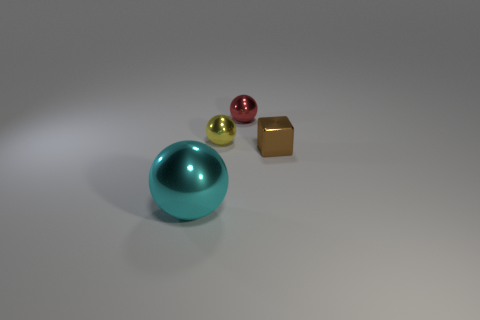Are there an equal number of red things left of the big cyan shiny thing and small yellow cylinders?
Your response must be concise. Yes. There is a cyan object that is made of the same material as the red thing; what is its shape?
Offer a very short reply. Sphere. What number of shiny things are either small yellow balls or yellow cylinders?
Your answer should be compact. 1. There is a metallic sphere that is behind the yellow ball; what number of tiny objects are in front of it?
Offer a very short reply. 2. How many brown blocks have the same material as the red ball?
Keep it short and to the point. 1. What number of tiny things are either purple metallic cylinders or red balls?
Your answer should be compact. 1. There is a shiny object that is both in front of the small yellow metal sphere and to the right of the large cyan metallic object; what is its shape?
Keep it short and to the point. Cube. Do the small red object and the tiny cube have the same material?
Offer a terse response. Yes. What color is the metal sphere that is the same size as the yellow thing?
Give a very brief answer. Red. What is the color of the metallic thing that is both in front of the yellow object and behind the large cyan ball?
Give a very brief answer. Brown. 